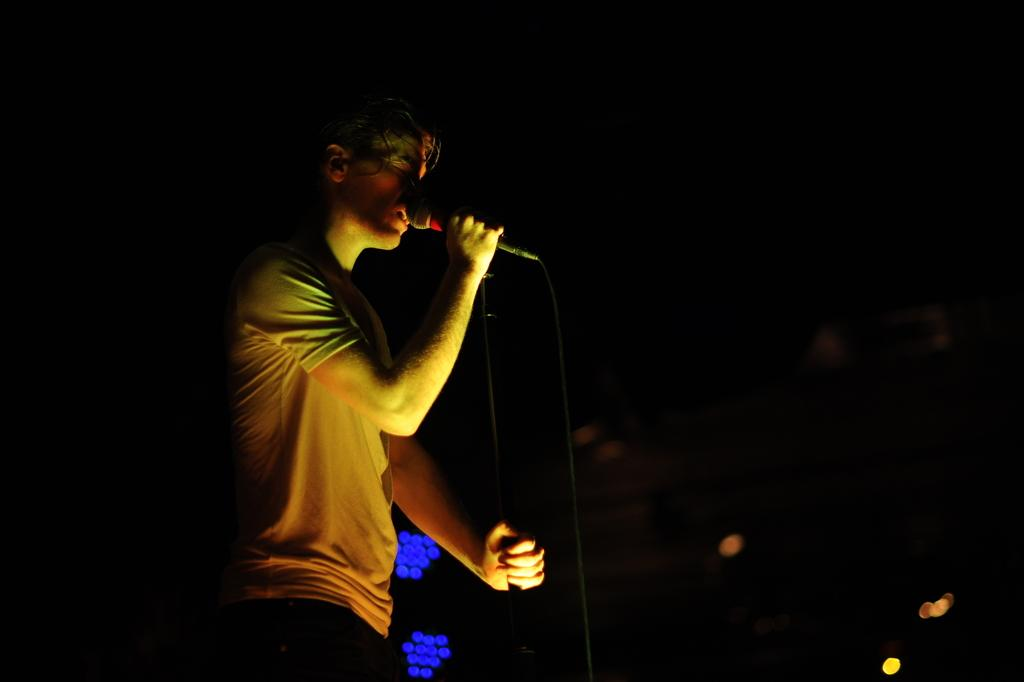What is the main subject of the image? There is a person in the image. What is the person holding in their hands? The person is holding a rod and a microphone with a wire. What can be observed about the lighting in the image? The background of the image is dark, but there are lights visible in the background. What type of news is the person reporting on in the image? There is no indication in the image that the person is reporting on any news. --- Facts: 1. There is a car in the image. 2. The car is parked on the side of the road. 3. There are trees in the background of the image. 4. The sky is visible in the image. 5. The car has a flat tire. Absurd Topics: parrot, dance, ocean Conversation: What is the main subject of the image? There is a car in the image. Where is the car located in the image? The car is parked on the side of the road. What can be seen in the background of the image? There are trees in the background of the image, and the sky is visible. What is the condition of the car in the image? The car has a flat tire. Reasoning: Let's think step by step in order to produce the conversation. We start by identifying the main subject of the image, which is the car. Then, we describe the car's location, noting that it is parked on the side of the road. Next, we mention the background of the image, which includes trees and the sky. Finally, we describe the condition of the car, which has a flat tire. Absurd Question/Answer: Can you see a parrot dancing on the ocean in the image? There is no parrot or ocean present in the image. 